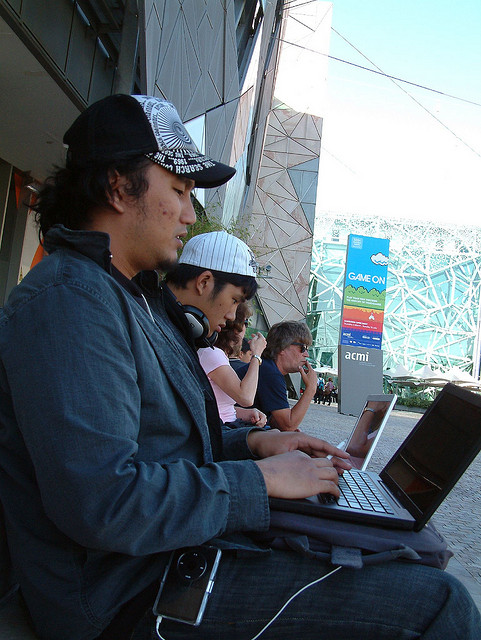<image>What color are the tables? There are no tables in the image. But if there were, they might be black, gray or brown. What color are the tables? I don't know what color the tables are. It is not clear from the given information. 